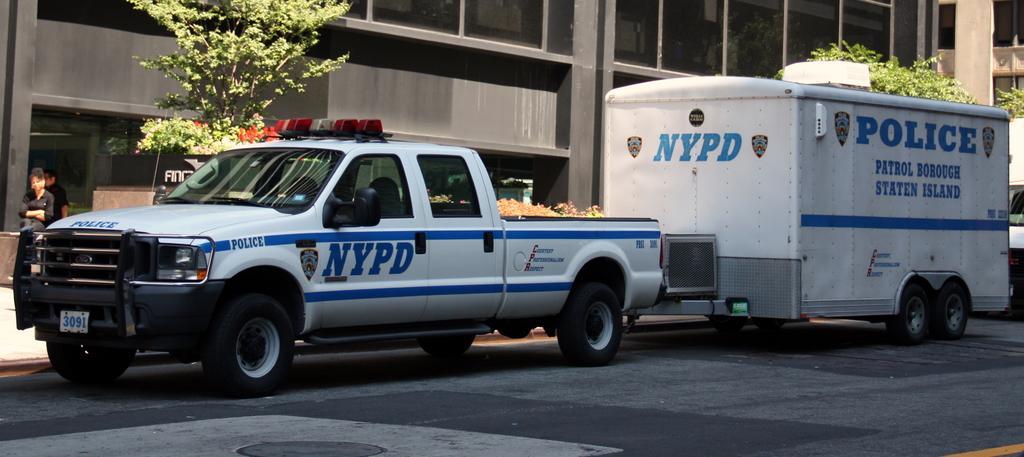Describe this image in one or two sentences. In the foreground of the image we can see vehicles parked on the road. On the left side of the image we can see two persons. In the background, we can see a group of trees, flowers, building and a sign board with some text. 